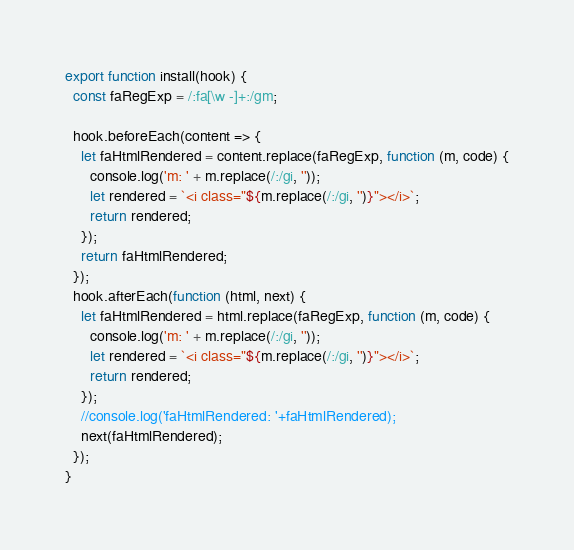Convert code to text. <code><loc_0><loc_0><loc_500><loc_500><_JavaScript_>export function install(hook) {
  const faRegExp = /:fa[\w -]+:/gm;

  hook.beforeEach(content => {
    let faHtmlRendered = content.replace(faRegExp, function (m, code) {
      console.log('m: ' + m.replace(/:/gi, ''));
      let rendered = `<i class="${m.replace(/:/gi, '')}"></i>`;
      return rendered;
    });
    return faHtmlRendered;
  });
  hook.afterEach(function (html, next) {
    let faHtmlRendered = html.replace(faRegExp, function (m, code) {
      console.log('m: ' + m.replace(/:/gi, ''));
      let rendered = `<i class="${m.replace(/:/gi, '')}"></i>`;
      return rendered;
    });
    //console.log('faHtmlRendered: '+faHtmlRendered);
    next(faHtmlRendered);
  });
}
</code> 